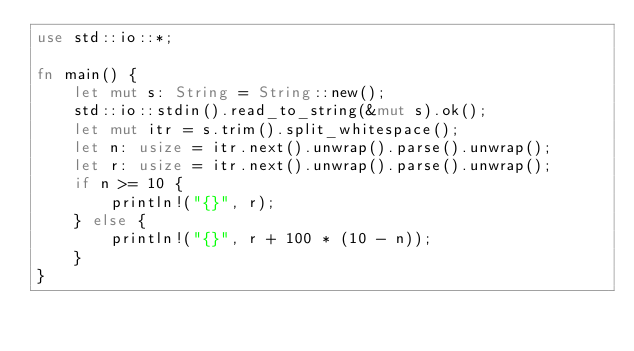Convert code to text. <code><loc_0><loc_0><loc_500><loc_500><_Rust_>use std::io::*;

fn main() {
    let mut s: String = String::new();
    std::io::stdin().read_to_string(&mut s).ok();
    let mut itr = s.trim().split_whitespace();
    let n: usize = itr.next().unwrap().parse().unwrap();
    let r: usize = itr.next().unwrap().parse().unwrap();
    if n >= 10 {
        println!("{}", r);
    } else {
        println!("{}", r + 100 * (10 - n));
    }
}
</code> 